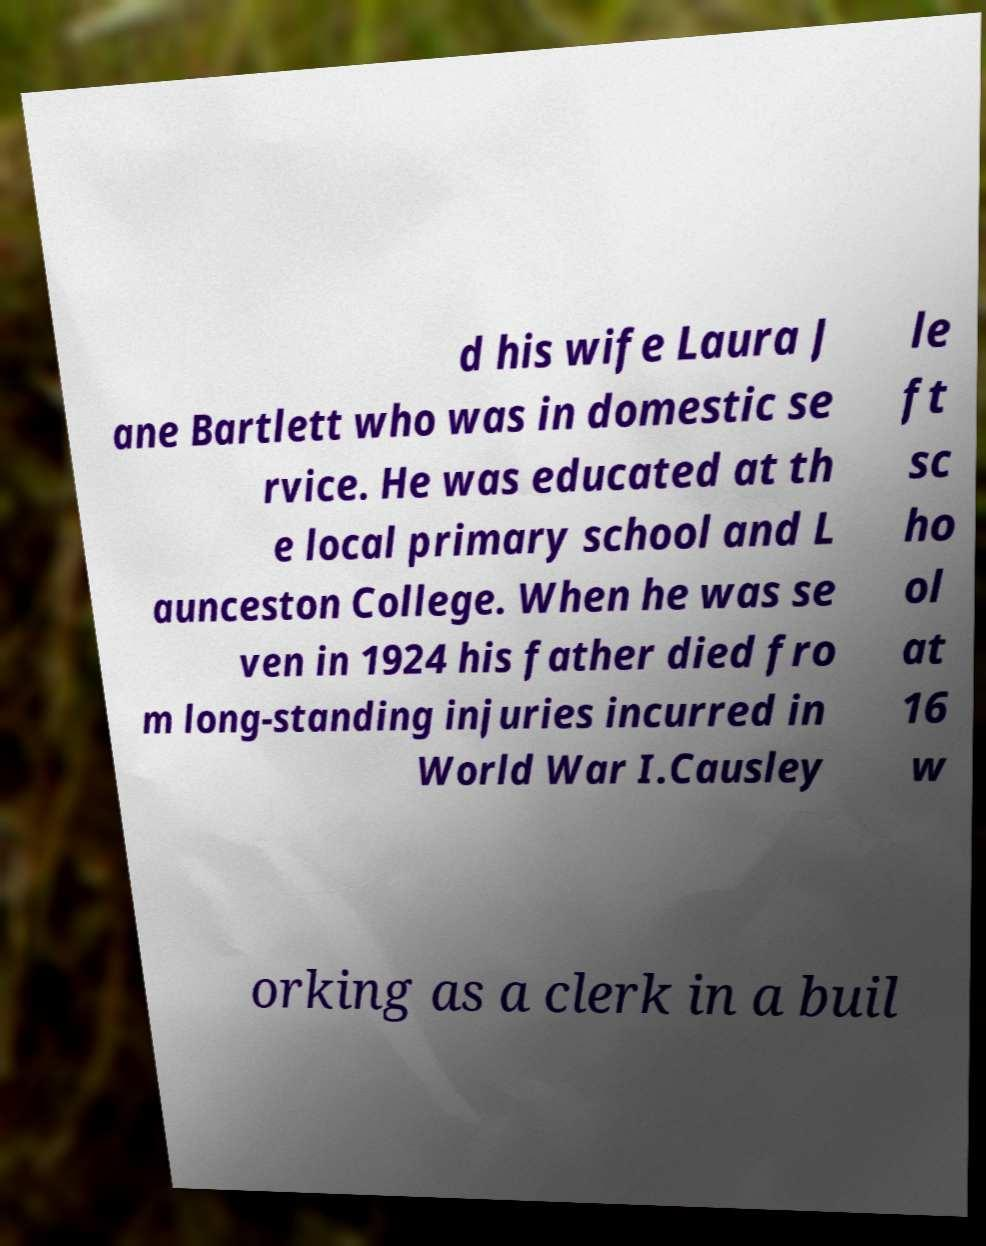Could you assist in decoding the text presented in this image and type it out clearly? d his wife Laura J ane Bartlett who was in domestic se rvice. He was educated at th e local primary school and L aunceston College. When he was se ven in 1924 his father died fro m long-standing injuries incurred in World War I.Causley le ft sc ho ol at 16 w orking as a clerk in a buil 